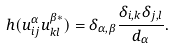<formula> <loc_0><loc_0><loc_500><loc_500>h ( u ^ { \alpha } _ { i j } u ^ { \beta \ast } _ { k l } ) = \delta _ { \alpha , \beta } \frac { \delta _ { i , k } \delta _ { j , l } } { d _ { \alpha } } .</formula> 